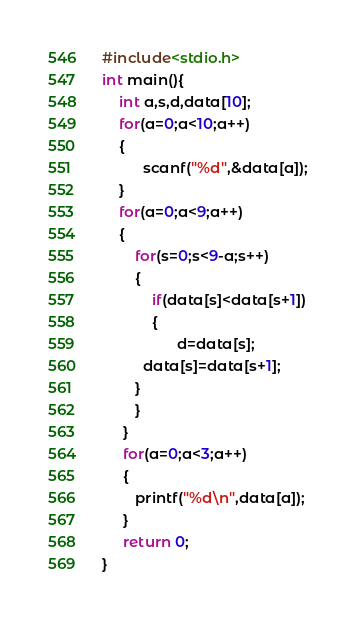Convert code to text. <code><loc_0><loc_0><loc_500><loc_500><_C_>#include<stdio.h>
int main(){
    int a,s,d,data[10];
    for(a=0;a<10;a++)
    {
          scanf("%d",&data[a]);
    }
    for(a=0;a<9;a++)
    {
        for(s=0;s<9-a;s++)
        {
            if(data[s]<data[s+1])
            {
                  d=data[s];
		  data[s]=data[s+1];
	    }
        }
     }
     for(a=0;a<3;a++)
     {
        printf("%d\n",data[a]);
     }
     return 0;
}</code> 